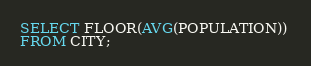Convert code to text. <code><loc_0><loc_0><loc_500><loc_500><_SQL_>SELECT FLOOR(AVG(POPULATION)) 
FROM CITY;</code> 